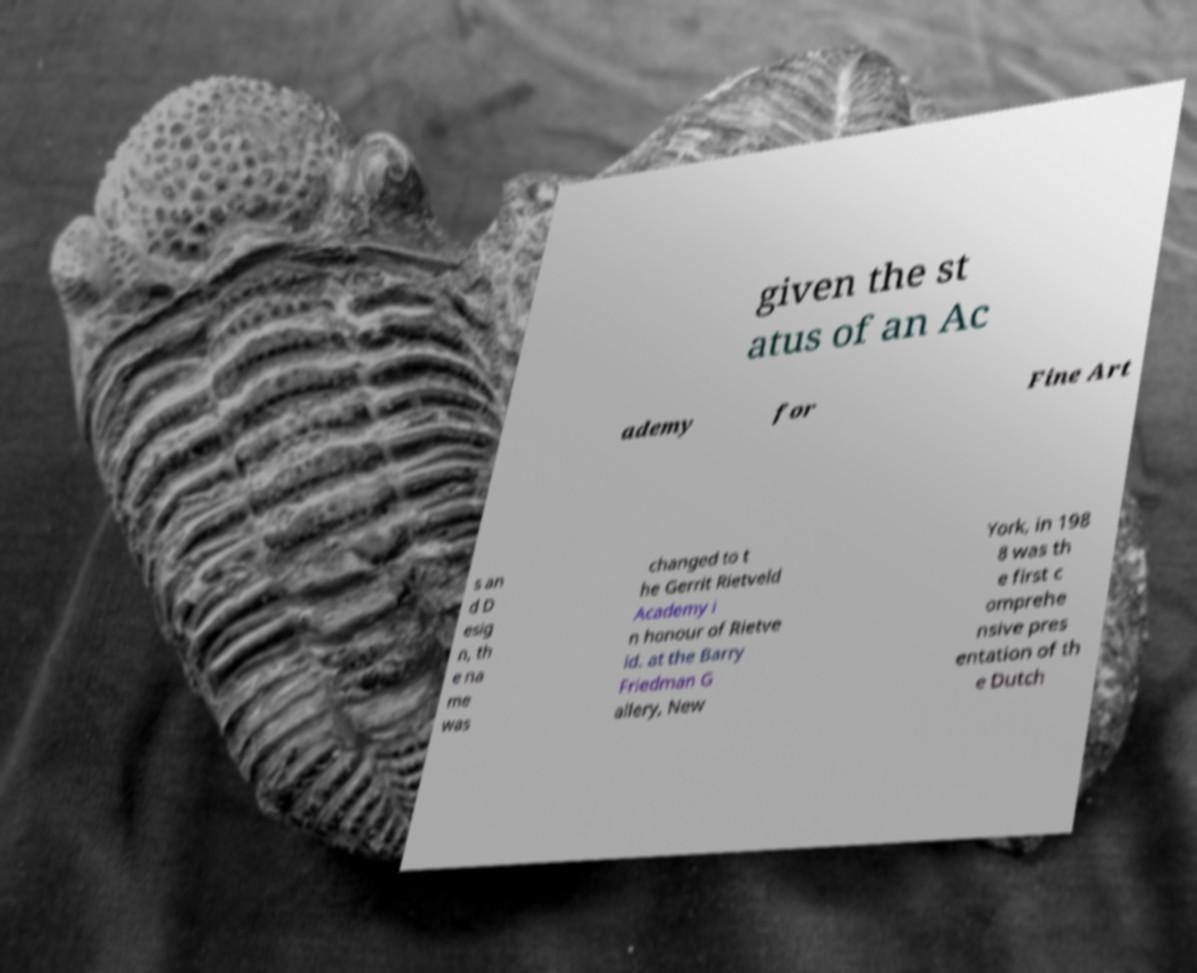Can you accurately transcribe the text from the provided image for me? given the st atus of an Ac ademy for Fine Art s an d D esig n, th e na me was changed to t he Gerrit Rietveld Academy i n honour of Rietve ld. at the Barry Friedman G allery, New York, in 198 8 was th e first c omprehe nsive pres entation of th e Dutch 